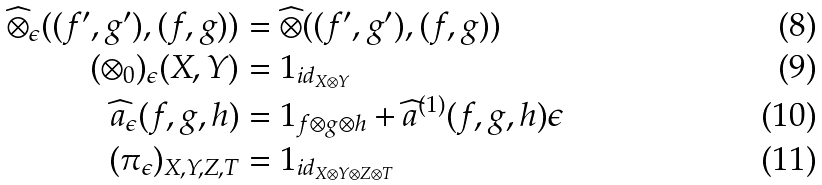Convert formula to latex. <formula><loc_0><loc_0><loc_500><loc_500>\widehat { \otimes } _ { \epsilon } ( ( f ^ { \prime } , g ^ { \prime } ) , ( f , g ) ) & = \widehat { \otimes } ( ( f ^ { \prime } , g ^ { \prime } ) , ( f , g ) ) \\ ( \otimes _ { 0 } ) _ { \epsilon } ( X , Y ) & = 1 _ { i d _ { X \otimes Y } } \\ \widehat { a } _ { \epsilon } ( f , g , h ) & = 1 _ { f \otimes g \otimes h } + \widehat { a } ^ { ( 1 ) } ( f , g , h ) \epsilon \\ ( \pi _ { \epsilon } ) _ { X , Y , Z , T } & = 1 _ { i d _ { X \otimes Y \otimes Z \otimes T } }</formula> 